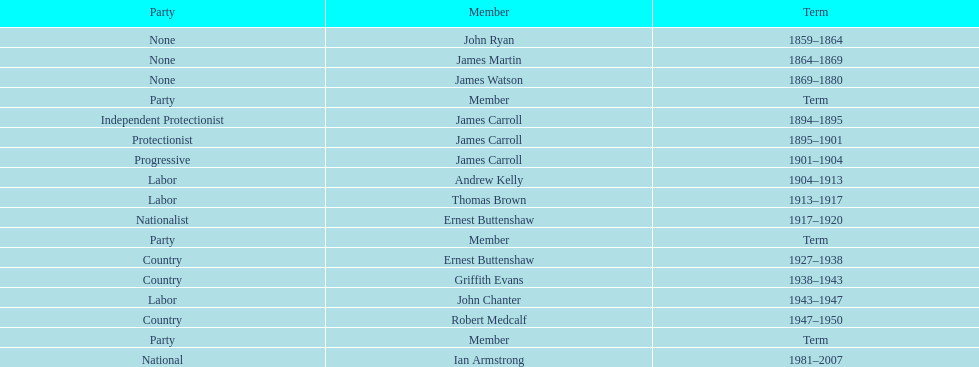Which member of the second incarnation of the lachlan was also a nationalist? Ernest Buttenshaw. 